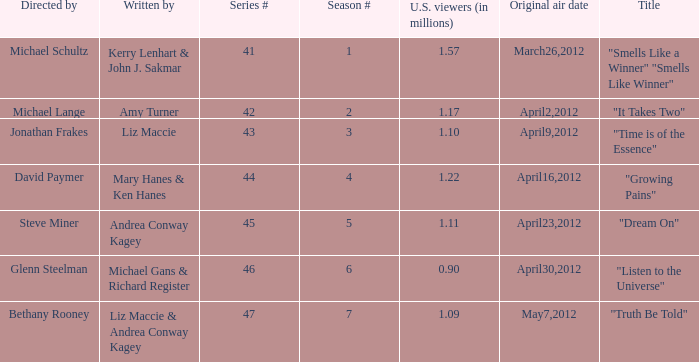What are the titles of the episodes which had 1.10 million U.S. viewers? "Time is of the Essence". 